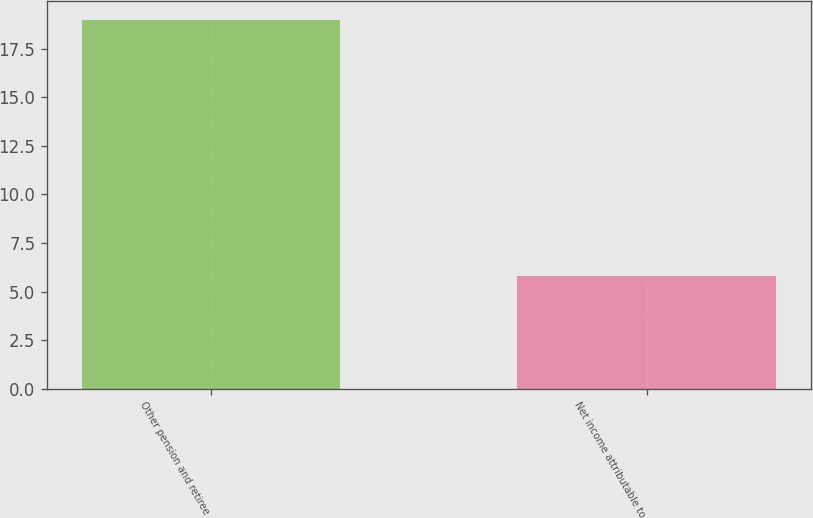Convert chart. <chart><loc_0><loc_0><loc_500><loc_500><bar_chart><fcel>Other pension and retiree<fcel>Net income attributable to<nl><fcel>19<fcel>5.82<nl></chart> 